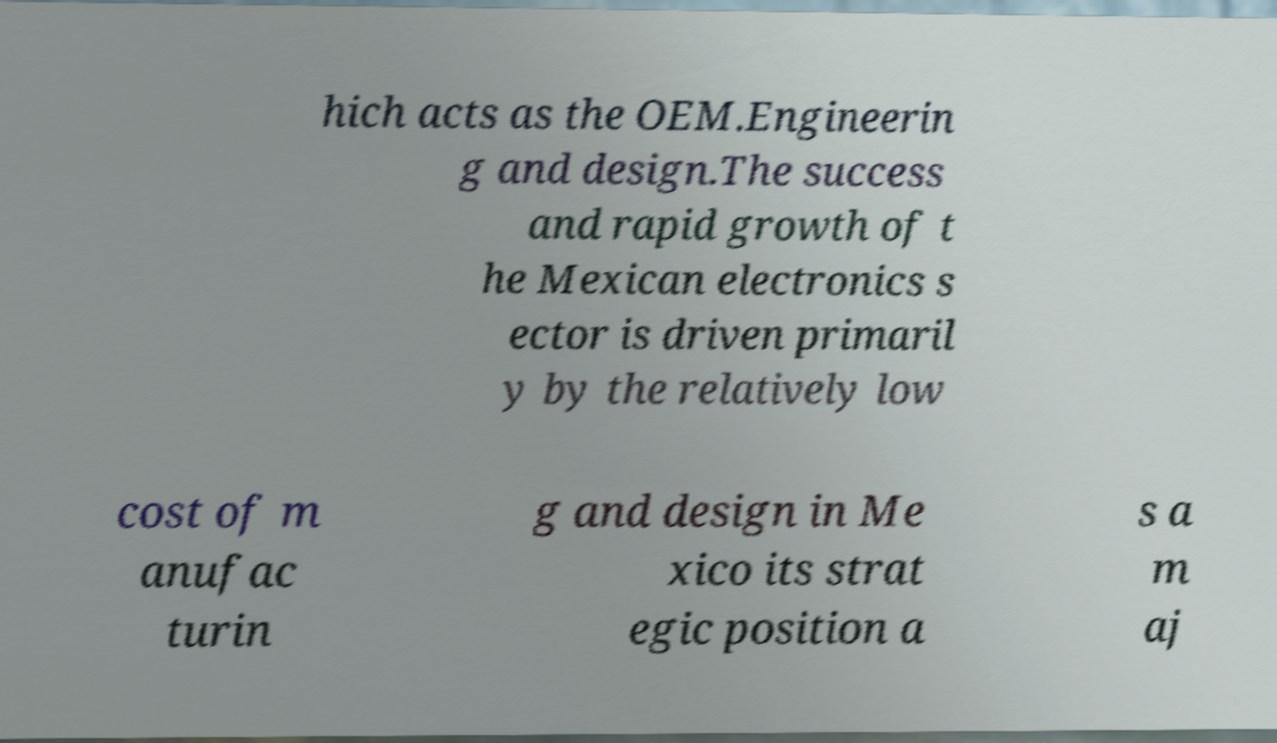Please read and relay the text visible in this image. What does it say? hich acts as the OEM.Engineerin g and design.The success and rapid growth of t he Mexican electronics s ector is driven primaril y by the relatively low cost of m anufac turin g and design in Me xico its strat egic position a s a m aj 